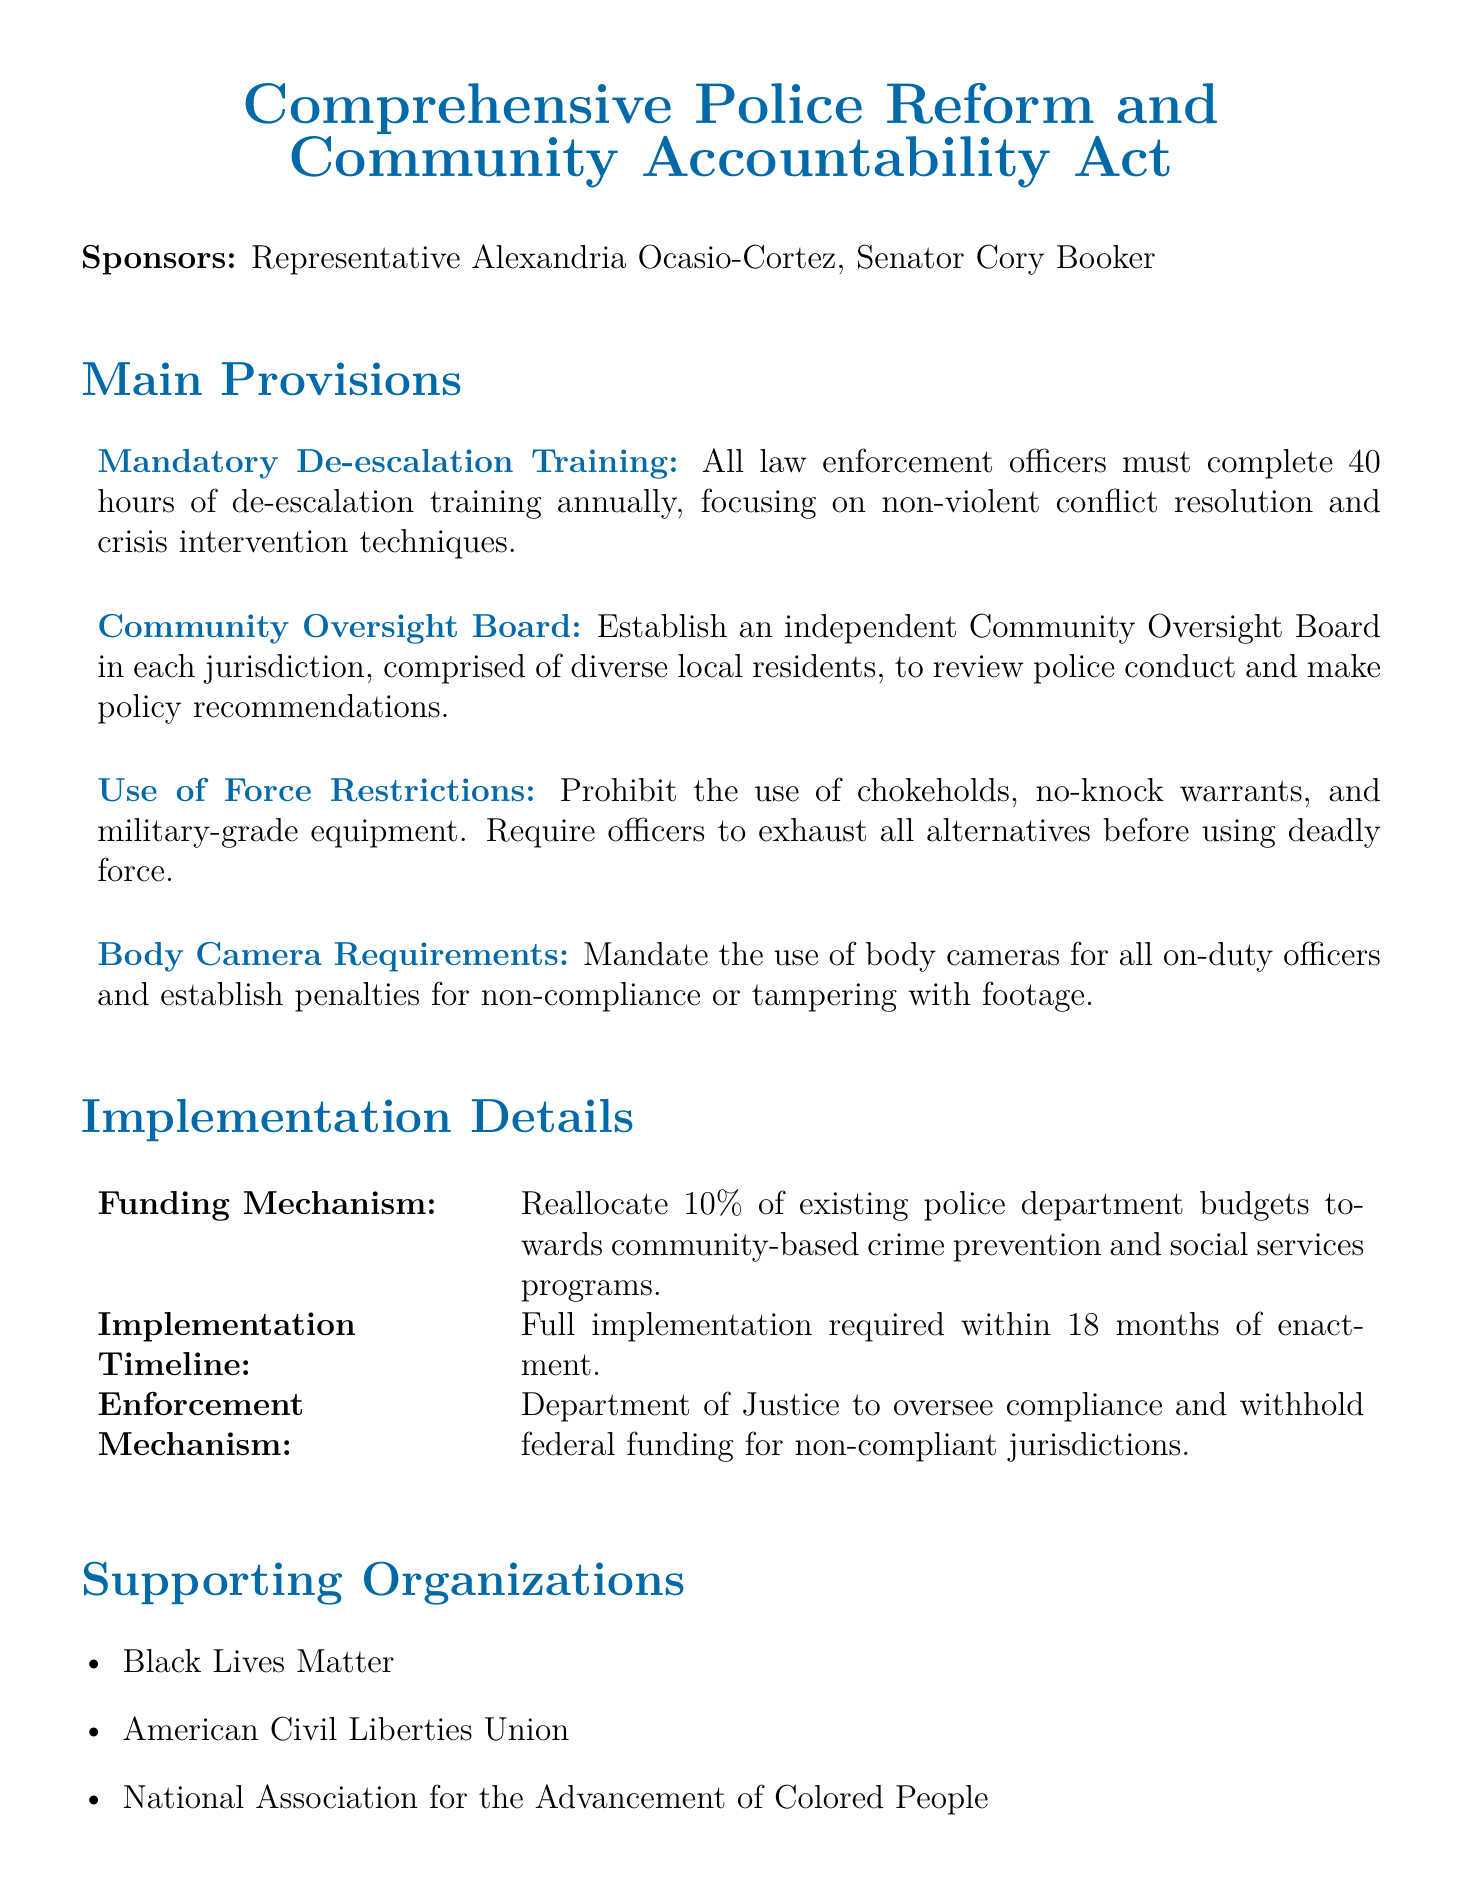What is the title of the bill? The title of the bill is presented in the header section of the document.
Answer: Comprehensive Police Reform and Community Accountability Act Who are the sponsors of the bill? The sponsors are listed right under the title, identifying the individuals supporting the bill.
Answer: Representative Alexandria Ocasio-Cortez, Senator Cory Booker How many hours of de-escalation training must law enforcement officers complete annually? This information is provided in the section outlining the main provisions of the bill.
Answer: 40 hours What is the reallocation percentage of police department budgets for community-based programs? This percentage is mentioned in the funding mechanism section of the document.
Answer: 10% What is the implementation timeline for the bill? The document specifies a requirement for when full implementation must occur after enactment.
Answer: 18 months What type of oversight does the bill propose for police conduct? This information can be found in the section detailing the main provisions of the bill.
Answer: Community Oversight Board Which organization is NOT mentioned as a supporter of the bill? This question involves reasoning about what organizations are listed under supporting organizations.
Answer: (Any organization not listed) What will the Department of Justice oversee according to the bill? The enforcement mechanism section details the role of the Department of Justice.
Answer: Compliance 